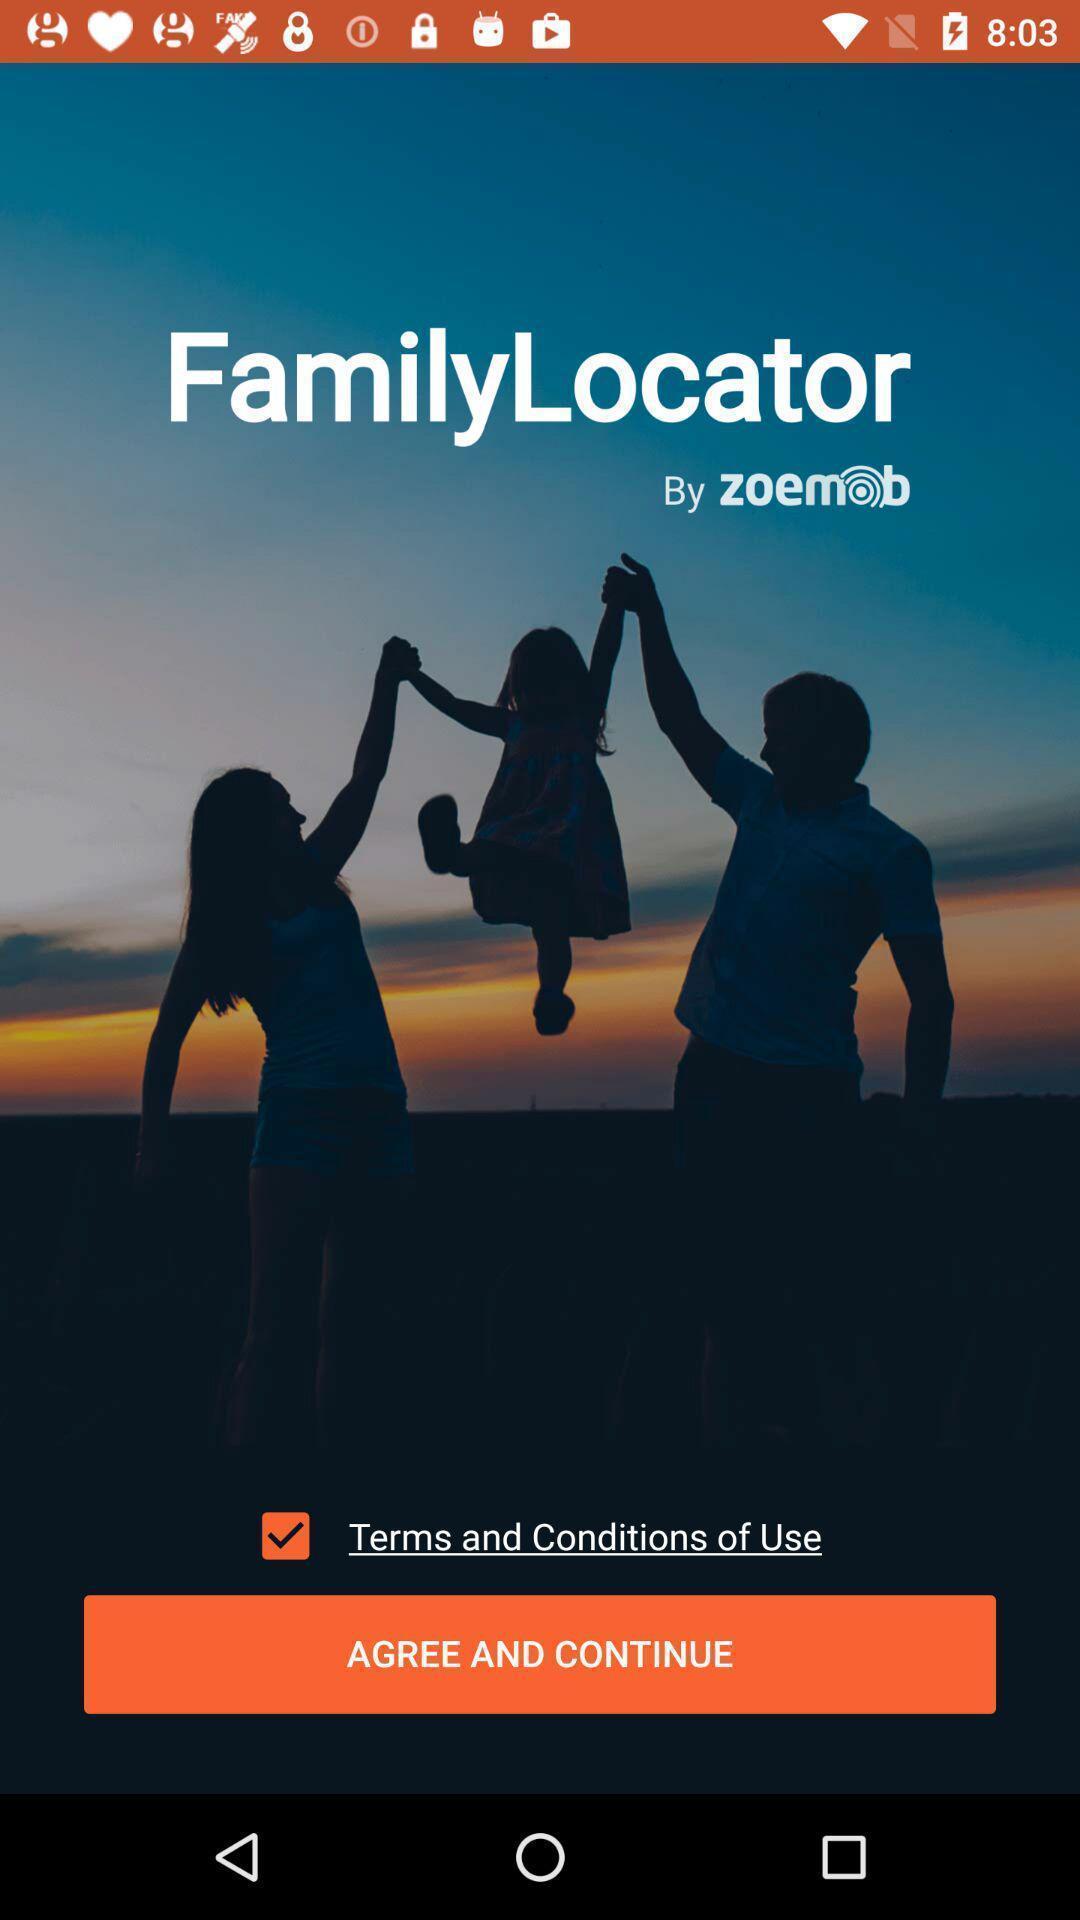Describe the visual elements of this screenshot. Welcome page to continue in a family locating app. 